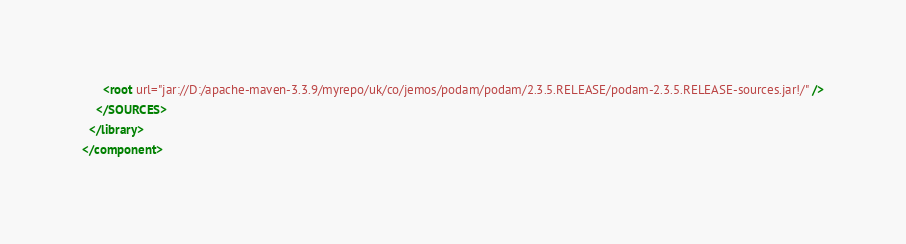<code> <loc_0><loc_0><loc_500><loc_500><_XML_>      <root url="jar://D:/apache-maven-3.3.9/myrepo/uk/co/jemos/podam/podam/2.3.5.RELEASE/podam-2.3.5.RELEASE-sources.jar!/" />
    </SOURCES>
  </library>
</component></code> 